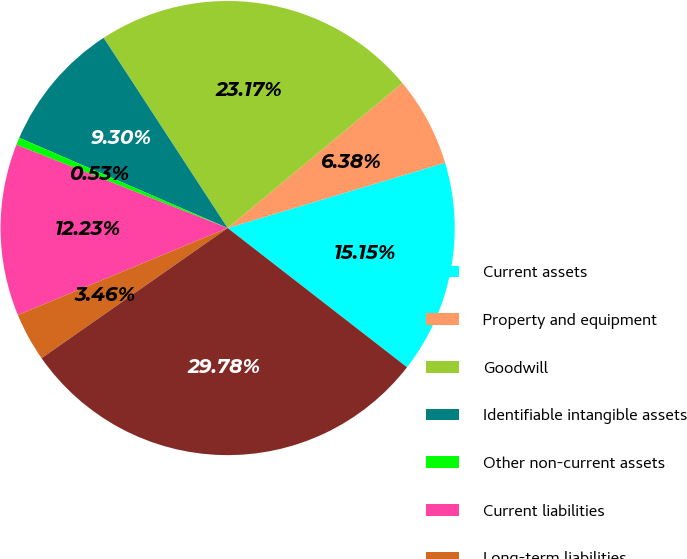Convert chart to OTSL. <chart><loc_0><loc_0><loc_500><loc_500><pie_chart><fcel>Current assets<fcel>Property and equipment<fcel>Goodwill<fcel>Identifiable intangible assets<fcel>Other non-current assets<fcel>Current liabilities<fcel>Long-term liabilities<fcel>Total purchase price<nl><fcel>15.15%<fcel>6.38%<fcel>23.17%<fcel>9.3%<fcel>0.53%<fcel>12.23%<fcel>3.46%<fcel>29.78%<nl></chart> 